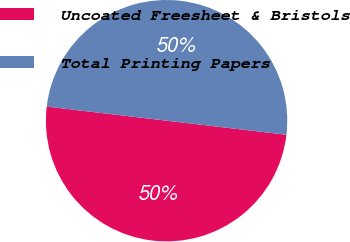Convert chart. <chart><loc_0><loc_0><loc_500><loc_500><pie_chart><fcel>Uncoated Freesheet & Bristols<fcel>Total Printing Papers<nl><fcel>50.0%<fcel>50.0%<nl></chart> 